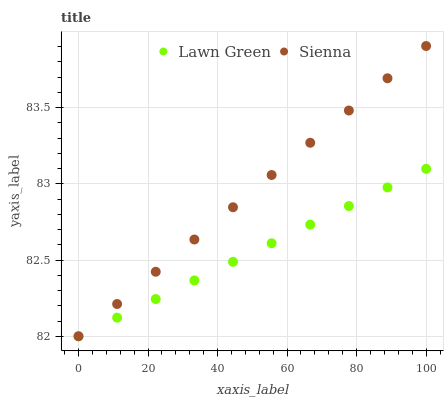Does Lawn Green have the minimum area under the curve?
Answer yes or no. Yes. Does Sienna have the maximum area under the curve?
Answer yes or no. Yes. Does Lawn Green have the maximum area under the curve?
Answer yes or no. No. Is Sienna the smoothest?
Answer yes or no. Yes. Is Lawn Green the roughest?
Answer yes or no. Yes. Is Lawn Green the smoothest?
Answer yes or no. No. Does Sienna have the lowest value?
Answer yes or no. Yes. Does Sienna have the highest value?
Answer yes or no. Yes. Does Lawn Green have the highest value?
Answer yes or no. No. Does Sienna intersect Lawn Green?
Answer yes or no. Yes. Is Sienna less than Lawn Green?
Answer yes or no. No. Is Sienna greater than Lawn Green?
Answer yes or no. No. 